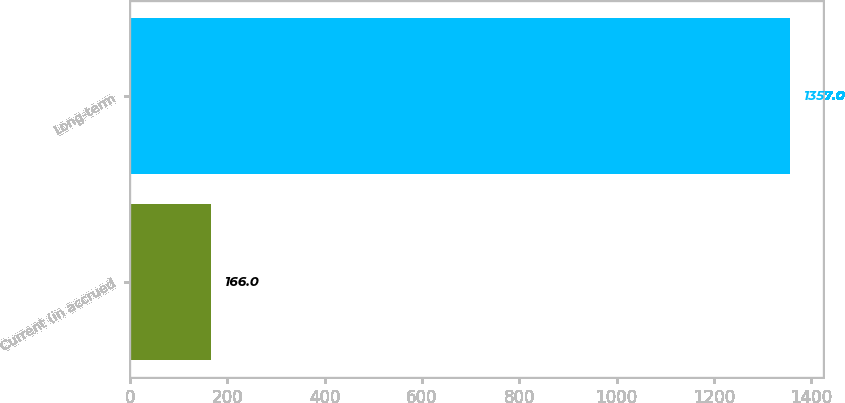Convert chart. <chart><loc_0><loc_0><loc_500><loc_500><bar_chart><fcel>Current (in accrued<fcel>Long-term<nl><fcel>166<fcel>1357<nl></chart> 